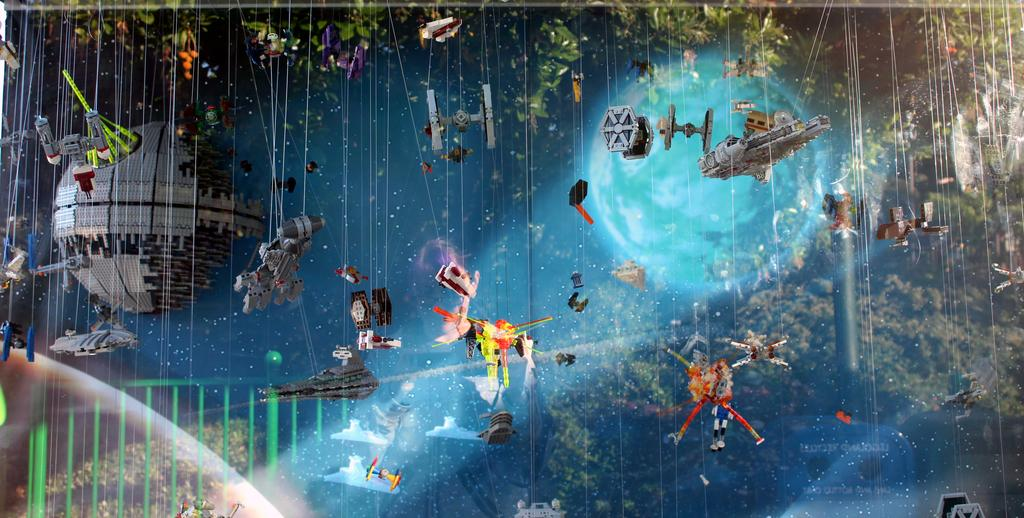What is hanging in the air in the image? Toys and objects tied to threads are hanging in the air in the image. What can be seen in the background of the image? There are globes, objects, and trees in the background of the image. Can you describe the toys and objects hanging in the air? They are tied to threads, but no specific details about their appearance are provided. How many police officers are present in the image? There is no mention of police officers in the image; it features toys and objects hanging in the air, as well as a background with globes, objects, and trees. Can you tell me the expertise of the person who tied the toys and objects to the threads? There is no information provided about the person who tied the toys and objects to the threads, nor is there any indication of their expertise. 